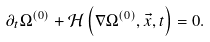<formula> <loc_0><loc_0><loc_500><loc_500>\partial _ { t } \Omega ^ { ( 0 ) } + \mathcal { H } \left ( \nabla { \Omega ^ { ( 0 ) } } , \vec { x } , t \right ) = 0 .</formula> 